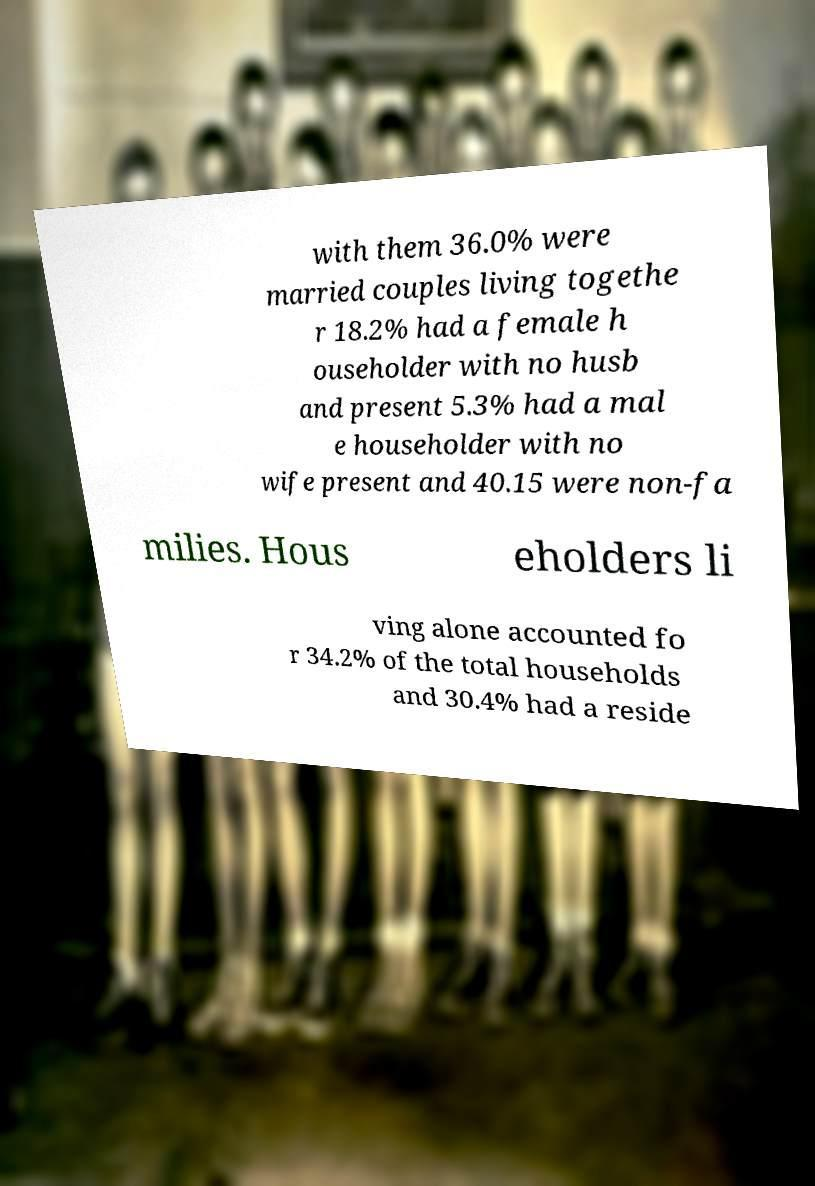Can you accurately transcribe the text from the provided image for me? with them 36.0% were married couples living togethe r 18.2% had a female h ouseholder with no husb and present 5.3% had a mal e householder with no wife present and 40.15 were non-fa milies. Hous eholders li ving alone accounted fo r 34.2% of the total households and 30.4% had a reside 